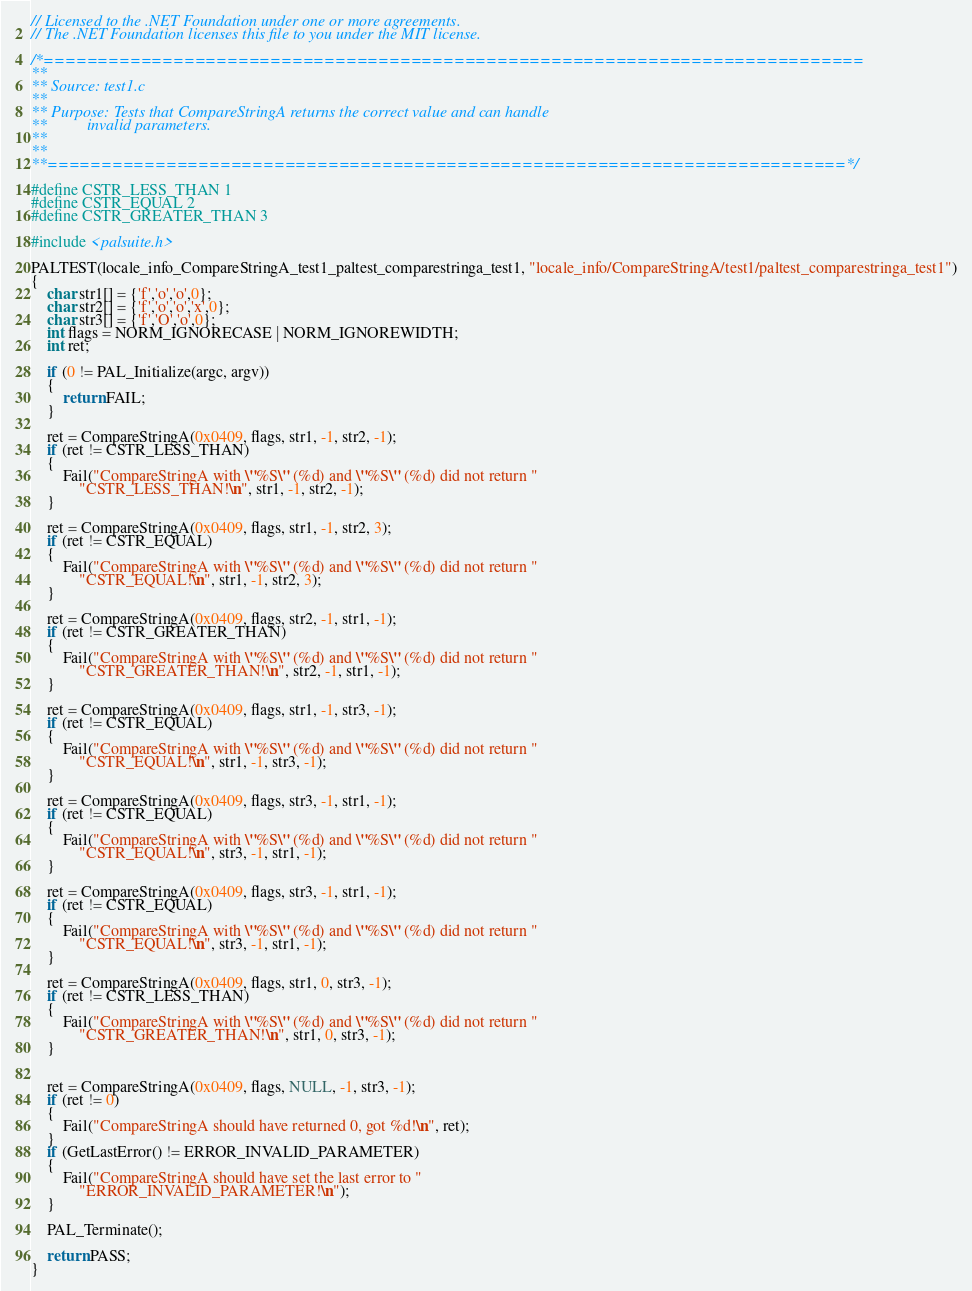<code> <loc_0><loc_0><loc_500><loc_500><_C++_>// Licensed to the .NET Foundation under one or more agreements.
// The .NET Foundation licenses this file to you under the MIT license.

/*============================================================================
**
** Source: test1.c
**
** Purpose: Tests that CompareStringA returns the correct value and can handle
**          invalid parameters.
**
**
**==========================================================================*/

#define CSTR_LESS_THAN 1
#define CSTR_EQUAL 2
#define CSTR_GREATER_THAN 3

#include <palsuite.h>

PALTEST(locale_info_CompareStringA_test1_paltest_comparestringa_test1, "locale_info/CompareStringA/test1/paltest_comparestringa_test1")
{    
    char str1[] = {'f','o','o',0};
    char str2[] = {'f','o','o','x',0};
    char str3[] = {'f','O','o',0};
    int flags = NORM_IGNORECASE | NORM_IGNOREWIDTH;
    int ret;

    if (0 != PAL_Initialize(argc, argv))
    {
        return FAIL;
    }

    ret = CompareStringA(0x0409, flags, str1, -1, str2, -1);
    if (ret != CSTR_LESS_THAN)
    {
        Fail("CompareStringA with \"%S\" (%d) and \"%S\" (%d) did not return "
            "CSTR_LESS_THAN!\n", str1, -1, str2, -1);
    }

    ret = CompareStringA(0x0409, flags, str1, -1, str2, 3);
    if (ret != CSTR_EQUAL)
    {
        Fail("CompareStringA with \"%S\" (%d) and \"%S\" (%d) did not return "
            "CSTR_EQUAL!\n", str1, -1, str2, 3);
    }

    ret = CompareStringA(0x0409, flags, str2, -1, str1, -1);
    if (ret != CSTR_GREATER_THAN)
    {
        Fail("CompareStringA with \"%S\" (%d) and \"%S\" (%d) did not return "
            "CSTR_GREATER_THAN!\n", str2, -1, str1, -1);
    }

    ret = CompareStringA(0x0409, flags, str1, -1, str3, -1);
    if (ret != CSTR_EQUAL)
    {
        Fail("CompareStringA with \"%S\" (%d) and \"%S\" (%d) did not return "
            "CSTR_EQUAL!\n", str1, -1, str3, -1);
    }

    ret = CompareStringA(0x0409, flags, str3, -1, str1, -1);
    if (ret != CSTR_EQUAL)
    {
        Fail("CompareStringA with \"%S\" (%d) and \"%S\" (%d) did not return "
            "CSTR_EQUAL!\n", str3, -1, str1, -1);
    }

    ret = CompareStringA(0x0409, flags, str3, -1, str1, -1);
    if (ret != CSTR_EQUAL)
    {
        Fail("CompareStringA with \"%S\" (%d) and \"%S\" (%d) did not return "
            "CSTR_EQUAL!\n", str3, -1, str1, -1);
    }

    ret = CompareStringA(0x0409, flags, str1, 0, str3, -1);
    if (ret != CSTR_LESS_THAN)
    {
        Fail("CompareStringA with \"%S\" (%d) and \"%S\" (%d) did not return "
            "CSTR_GREATER_THAN!\n", str1, 0, str3, -1);
    }

    
    ret = CompareStringA(0x0409, flags, NULL, -1, str3, -1);
    if (ret != 0)
    {
        Fail("CompareStringA should have returned 0, got %d!\n", ret);
    }
    if (GetLastError() != ERROR_INVALID_PARAMETER)
    {
        Fail("CompareStringA should have set the last error to "
            "ERROR_INVALID_PARAMETER!\n");
    }

    PAL_Terminate();

    return PASS;
}

</code> 